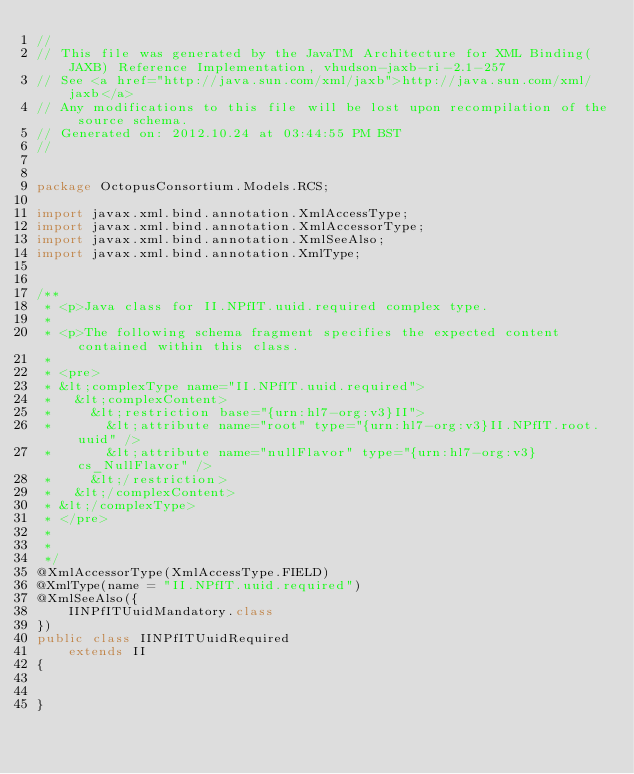Convert code to text. <code><loc_0><loc_0><loc_500><loc_500><_Java_>//
// This file was generated by the JavaTM Architecture for XML Binding(JAXB) Reference Implementation, vhudson-jaxb-ri-2.1-257 
// See <a href="http://java.sun.com/xml/jaxb">http://java.sun.com/xml/jaxb</a> 
// Any modifications to this file will be lost upon recompilation of the source schema. 
// Generated on: 2012.10.24 at 03:44:55 PM BST 
//


package OctopusConsortium.Models.RCS;

import javax.xml.bind.annotation.XmlAccessType;
import javax.xml.bind.annotation.XmlAccessorType;
import javax.xml.bind.annotation.XmlSeeAlso;
import javax.xml.bind.annotation.XmlType;


/**
 * <p>Java class for II.NPfIT.uuid.required complex type.
 * 
 * <p>The following schema fragment specifies the expected content contained within this class.
 * 
 * <pre>
 * &lt;complexType name="II.NPfIT.uuid.required">
 *   &lt;complexContent>
 *     &lt;restriction base="{urn:hl7-org:v3}II">
 *       &lt;attribute name="root" type="{urn:hl7-org:v3}II.NPfIT.root.uuid" />
 *       &lt;attribute name="nullFlavor" type="{urn:hl7-org:v3}cs_NullFlavor" />
 *     &lt;/restriction>
 *   &lt;/complexContent>
 * &lt;/complexType>
 * </pre>
 * 
 * 
 */
@XmlAccessorType(XmlAccessType.FIELD)
@XmlType(name = "II.NPfIT.uuid.required")
@XmlSeeAlso({
    IINPfITUuidMandatory.class
})
public class IINPfITUuidRequired
    extends II
{


}
</code> 